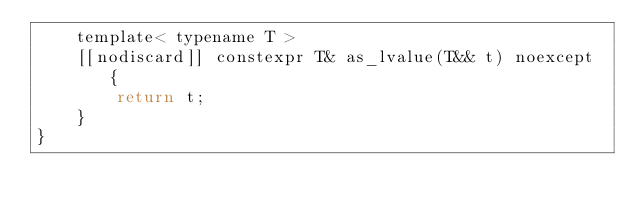Convert code to text. <code><loc_0><loc_0><loc_500><loc_500><_C_>	template< typename T >
	[[nodiscard]] constexpr T& as_lvalue(T&& t) noexcept {
		return t;
	}
}</code> 